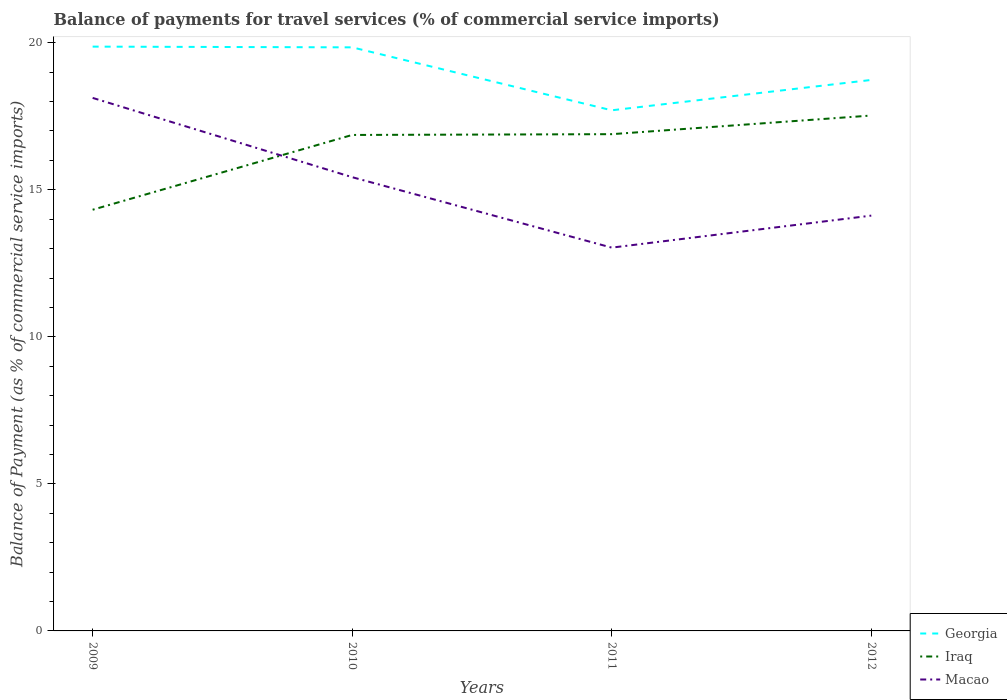Is the number of lines equal to the number of legend labels?
Your answer should be compact. Yes. Across all years, what is the maximum balance of payments for travel services in Georgia?
Offer a terse response. 17.7. In which year was the balance of payments for travel services in Macao maximum?
Ensure brevity in your answer.  2011. What is the total balance of payments for travel services in Macao in the graph?
Provide a succinct answer. 2.4. What is the difference between the highest and the second highest balance of payments for travel services in Macao?
Provide a succinct answer. 5.09. What is the difference between the highest and the lowest balance of payments for travel services in Macao?
Give a very brief answer. 2. Is the balance of payments for travel services in Georgia strictly greater than the balance of payments for travel services in Iraq over the years?
Give a very brief answer. No. What is the difference between two consecutive major ticks on the Y-axis?
Offer a terse response. 5. Are the values on the major ticks of Y-axis written in scientific E-notation?
Your answer should be compact. No. Does the graph contain any zero values?
Give a very brief answer. No. Does the graph contain grids?
Your answer should be very brief. No. Where does the legend appear in the graph?
Keep it short and to the point. Bottom right. What is the title of the graph?
Give a very brief answer. Balance of payments for travel services (% of commercial service imports). What is the label or title of the X-axis?
Keep it short and to the point. Years. What is the label or title of the Y-axis?
Your answer should be very brief. Balance of Payment (as % of commercial service imports). What is the Balance of Payment (as % of commercial service imports) of Georgia in 2009?
Keep it short and to the point. 19.87. What is the Balance of Payment (as % of commercial service imports) of Iraq in 2009?
Keep it short and to the point. 14.32. What is the Balance of Payment (as % of commercial service imports) in Macao in 2009?
Your answer should be compact. 18.12. What is the Balance of Payment (as % of commercial service imports) in Georgia in 2010?
Ensure brevity in your answer.  19.84. What is the Balance of Payment (as % of commercial service imports) in Iraq in 2010?
Your response must be concise. 16.86. What is the Balance of Payment (as % of commercial service imports) in Macao in 2010?
Give a very brief answer. 15.43. What is the Balance of Payment (as % of commercial service imports) in Georgia in 2011?
Offer a terse response. 17.7. What is the Balance of Payment (as % of commercial service imports) in Iraq in 2011?
Make the answer very short. 16.89. What is the Balance of Payment (as % of commercial service imports) of Macao in 2011?
Provide a short and direct response. 13.03. What is the Balance of Payment (as % of commercial service imports) of Georgia in 2012?
Your answer should be very brief. 18.73. What is the Balance of Payment (as % of commercial service imports) in Iraq in 2012?
Offer a terse response. 17.52. What is the Balance of Payment (as % of commercial service imports) in Macao in 2012?
Offer a terse response. 14.12. Across all years, what is the maximum Balance of Payment (as % of commercial service imports) in Georgia?
Make the answer very short. 19.87. Across all years, what is the maximum Balance of Payment (as % of commercial service imports) in Iraq?
Provide a succinct answer. 17.52. Across all years, what is the maximum Balance of Payment (as % of commercial service imports) of Macao?
Give a very brief answer. 18.12. Across all years, what is the minimum Balance of Payment (as % of commercial service imports) of Georgia?
Keep it short and to the point. 17.7. Across all years, what is the minimum Balance of Payment (as % of commercial service imports) in Iraq?
Provide a short and direct response. 14.32. Across all years, what is the minimum Balance of Payment (as % of commercial service imports) of Macao?
Offer a terse response. 13.03. What is the total Balance of Payment (as % of commercial service imports) in Georgia in the graph?
Your response must be concise. 76.15. What is the total Balance of Payment (as % of commercial service imports) of Iraq in the graph?
Your answer should be very brief. 65.6. What is the total Balance of Payment (as % of commercial service imports) of Macao in the graph?
Provide a succinct answer. 60.71. What is the difference between the Balance of Payment (as % of commercial service imports) in Georgia in 2009 and that in 2010?
Ensure brevity in your answer.  0.02. What is the difference between the Balance of Payment (as % of commercial service imports) of Iraq in 2009 and that in 2010?
Your response must be concise. -2.54. What is the difference between the Balance of Payment (as % of commercial service imports) of Macao in 2009 and that in 2010?
Provide a succinct answer. 2.7. What is the difference between the Balance of Payment (as % of commercial service imports) in Georgia in 2009 and that in 2011?
Make the answer very short. 2.16. What is the difference between the Balance of Payment (as % of commercial service imports) in Iraq in 2009 and that in 2011?
Your response must be concise. -2.57. What is the difference between the Balance of Payment (as % of commercial service imports) of Macao in 2009 and that in 2011?
Give a very brief answer. 5.09. What is the difference between the Balance of Payment (as % of commercial service imports) of Georgia in 2009 and that in 2012?
Keep it short and to the point. 1.13. What is the difference between the Balance of Payment (as % of commercial service imports) in Iraq in 2009 and that in 2012?
Make the answer very short. -3.2. What is the difference between the Balance of Payment (as % of commercial service imports) in Macao in 2009 and that in 2012?
Keep it short and to the point. 4. What is the difference between the Balance of Payment (as % of commercial service imports) in Georgia in 2010 and that in 2011?
Give a very brief answer. 2.14. What is the difference between the Balance of Payment (as % of commercial service imports) in Iraq in 2010 and that in 2011?
Offer a very short reply. -0.03. What is the difference between the Balance of Payment (as % of commercial service imports) of Macao in 2010 and that in 2011?
Give a very brief answer. 2.4. What is the difference between the Balance of Payment (as % of commercial service imports) in Georgia in 2010 and that in 2012?
Offer a terse response. 1.11. What is the difference between the Balance of Payment (as % of commercial service imports) in Iraq in 2010 and that in 2012?
Make the answer very short. -0.66. What is the difference between the Balance of Payment (as % of commercial service imports) in Macao in 2010 and that in 2012?
Ensure brevity in your answer.  1.31. What is the difference between the Balance of Payment (as % of commercial service imports) of Georgia in 2011 and that in 2012?
Your answer should be very brief. -1.03. What is the difference between the Balance of Payment (as % of commercial service imports) in Iraq in 2011 and that in 2012?
Keep it short and to the point. -0.63. What is the difference between the Balance of Payment (as % of commercial service imports) in Macao in 2011 and that in 2012?
Your response must be concise. -1.09. What is the difference between the Balance of Payment (as % of commercial service imports) in Georgia in 2009 and the Balance of Payment (as % of commercial service imports) in Iraq in 2010?
Provide a short and direct response. 3. What is the difference between the Balance of Payment (as % of commercial service imports) in Georgia in 2009 and the Balance of Payment (as % of commercial service imports) in Macao in 2010?
Ensure brevity in your answer.  4.44. What is the difference between the Balance of Payment (as % of commercial service imports) in Iraq in 2009 and the Balance of Payment (as % of commercial service imports) in Macao in 2010?
Offer a terse response. -1.11. What is the difference between the Balance of Payment (as % of commercial service imports) in Georgia in 2009 and the Balance of Payment (as % of commercial service imports) in Iraq in 2011?
Provide a succinct answer. 2.98. What is the difference between the Balance of Payment (as % of commercial service imports) in Georgia in 2009 and the Balance of Payment (as % of commercial service imports) in Macao in 2011?
Ensure brevity in your answer.  6.83. What is the difference between the Balance of Payment (as % of commercial service imports) in Iraq in 2009 and the Balance of Payment (as % of commercial service imports) in Macao in 2011?
Offer a terse response. 1.29. What is the difference between the Balance of Payment (as % of commercial service imports) in Georgia in 2009 and the Balance of Payment (as % of commercial service imports) in Iraq in 2012?
Provide a short and direct response. 2.34. What is the difference between the Balance of Payment (as % of commercial service imports) of Georgia in 2009 and the Balance of Payment (as % of commercial service imports) of Macao in 2012?
Make the answer very short. 5.75. What is the difference between the Balance of Payment (as % of commercial service imports) of Iraq in 2009 and the Balance of Payment (as % of commercial service imports) of Macao in 2012?
Offer a very short reply. 0.2. What is the difference between the Balance of Payment (as % of commercial service imports) of Georgia in 2010 and the Balance of Payment (as % of commercial service imports) of Iraq in 2011?
Provide a short and direct response. 2.95. What is the difference between the Balance of Payment (as % of commercial service imports) of Georgia in 2010 and the Balance of Payment (as % of commercial service imports) of Macao in 2011?
Your response must be concise. 6.81. What is the difference between the Balance of Payment (as % of commercial service imports) of Iraq in 2010 and the Balance of Payment (as % of commercial service imports) of Macao in 2011?
Provide a short and direct response. 3.83. What is the difference between the Balance of Payment (as % of commercial service imports) in Georgia in 2010 and the Balance of Payment (as % of commercial service imports) in Iraq in 2012?
Offer a very short reply. 2.32. What is the difference between the Balance of Payment (as % of commercial service imports) of Georgia in 2010 and the Balance of Payment (as % of commercial service imports) of Macao in 2012?
Keep it short and to the point. 5.72. What is the difference between the Balance of Payment (as % of commercial service imports) of Iraq in 2010 and the Balance of Payment (as % of commercial service imports) of Macao in 2012?
Offer a terse response. 2.74. What is the difference between the Balance of Payment (as % of commercial service imports) in Georgia in 2011 and the Balance of Payment (as % of commercial service imports) in Iraq in 2012?
Offer a very short reply. 0.18. What is the difference between the Balance of Payment (as % of commercial service imports) in Georgia in 2011 and the Balance of Payment (as % of commercial service imports) in Macao in 2012?
Offer a terse response. 3.58. What is the difference between the Balance of Payment (as % of commercial service imports) of Iraq in 2011 and the Balance of Payment (as % of commercial service imports) of Macao in 2012?
Offer a terse response. 2.77. What is the average Balance of Payment (as % of commercial service imports) of Georgia per year?
Your answer should be very brief. 19.04. What is the average Balance of Payment (as % of commercial service imports) in Macao per year?
Give a very brief answer. 15.18. In the year 2009, what is the difference between the Balance of Payment (as % of commercial service imports) in Georgia and Balance of Payment (as % of commercial service imports) in Iraq?
Offer a very short reply. 5.55. In the year 2009, what is the difference between the Balance of Payment (as % of commercial service imports) in Georgia and Balance of Payment (as % of commercial service imports) in Macao?
Give a very brief answer. 1.74. In the year 2009, what is the difference between the Balance of Payment (as % of commercial service imports) in Iraq and Balance of Payment (as % of commercial service imports) in Macao?
Give a very brief answer. -3.8. In the year 2010, what is the difference between the Balance of Payment (as % of commercial service imports) of Georgia and Balance of Payment (as % of commercial service imports) of Iraq?
Provide a short and direct response. 2.98. In the year 2010, what is the difference between the Balance of Payment (as % of commercial service imports) in Georgia and Balance of Payment (as % of commercial service imports) in Macao?
Keep it short and to the point. 4.41. In the year 2010, what is the difference between the Balance of Payment (as % of commercial service imports) of Iraq and Balance of Payment (as % of commercial service imports) of Macao?
Keep it short and to the point. 1.44. In the year 2011, what is the difference between the Balance of Payment (as % of commercial service imports) of Georgia and Balance of Payment (as % of commercial service imports) of Iraq?
Your response must be concise. 0.81. In the year 2011, what is the difference between the Balance of Payment (as % of commercial service imports) in Georgia and Balance of Payment (as % of commercial service imports) in Macao?
Make the answer very short. 4.67. In the year 2011, what is the difference between the Balance of Payment (as % of commercial service imports) in Iraq and Balance of Payment (as % of commercial service imports) in Macao?
Provide a short and direct response. 3.86. In the year 2012, what is the difference between the Balance of Payment (as % of commercial service imports) in Georgia and Balance of Payment (as % of commercial service imports) in Iraq?
Give a very brief answer. 1.21. In the year 2012, what is the difference between the Balance of Payment (as % of commercial service imports) of Georgia and Balance of Payment (as % of commercial service imports) of Macao?
Ensure brevity in your answer.  4.61. In the year 2012, what is the difference between the Balance of Payment (as % of commercial service imports) in Iraq and Balance of Payment (as % of commercial service imports) in Macao?
Your answer should be very brief. 3.4. What is the ratio of the Balance of Payment (as % of commercial service imports) of Georgia in 2009 to that in 2010?
Provide a short and direct response. 1. What is the ratio of the Balance of Payment (as % of commercial service imports) in Iraq in 2009 to that in 2010?
Provide a short and direct response. 0.85. What is the ratio of the Balance of Payment (as % of commercial service imports) in Macao in 2009 to that in 2010?
Offer a terse response. 1.17. What is the ratio of the Balance of Payment (as % of commercial service imports) of Georgia in 2009 to that in 2011?
Provide a short and direct response. 1.12. What is the ratio of the Balance of Payment (as % of commercial service imports) of Iraq in 2009 to that in 2011?
Your answer should be compact. 0.85. What is the ratio of the Balance of Payment (as % of commercial service imports) of Macao in 2009 to that in 2011?
Keep it short and to the point. 1.39. What is the ratio of the Balance of Payment (as % of commercial service imports) of Georgia in 2009 to that in 2012?
Your answer should be very brief. 1.06. What is the ratio of the Balance of Payment (as % of commercial service imports) in Iraq in 2009 to that in 2012?
Offer a very short reply. 0.82. What is the ratio of the Balance of Payment (as % of commercial service imports) of Macao in 2009 to that in 2012?
Offer a terse response. 1.28. What is the ratio of the Balance of Payment (as % of commercial service imports) of Georgia in 2010 to that in 2011?
Offer a terse response. 1.12. What is the ratio of the Balance of Payment (as % of commercial service imports) of Macao in 2010 to that in 2011?
Offer a terse response. 1.18. What is the ratio of the Balance of Payment (as % of commercial service imports) in Georgia in 2010 to that in 2012?
Give a very brief answer. 1.06. What is the ratio of the Balance of Payment (as % of commercial service imports) in Iraq in 2010 to that in 2012?
Your answer should be compact. 0.96. What is the ratio of the Balance of Payment (as % of commercial service imports) in Macao in 2010 to that in 2012?
Provide a succinct answer. 1.09. What is the ratio of the Balance of Payment (as % of commercial service imports) in Georgia in 2011 to that in 2012?
Ensure brevity in your answer.  0.94. What is the ratio of the Balance of Payment (as % of commercial service imports) in Iraq in 2011 to that in 2012?
Make the answer very short. 0.96. What is the ratio of the Balance of Payment (as % of commercial service imports) in Macao in 2011 to that in 2012?
Give a very brief answer. 0.92. What is the difference between the highest and the second highest Balance of Payment (as % of commercial service imports) in Georgia?
Provide a succinct answer. 0.02. What is the difference between the highest and the second highest Balance of Payment (as % of commercial service imports) in Iraq?
Your answer should be very brief. 0.63. What is the difference between the highest and the second highest Balance of Payment (as % of commercial service imports) of Macao?
Your answer should be very brief. 2.7. What is the difference between the highest and the lowest Balance of Payment (as % of commercial service imports) in Georgia?
Provide a succinct answer. 2.16. What is the difference between the highest and the lowest Balance of Payment (as % of commercial service imports) in Iraq?
Make the answer very short. 3.2. What is the difference between the highest and the lowest Balance of Payment (as % of commercial service imports) of Macao?
Your response must be concise. 5.09. 